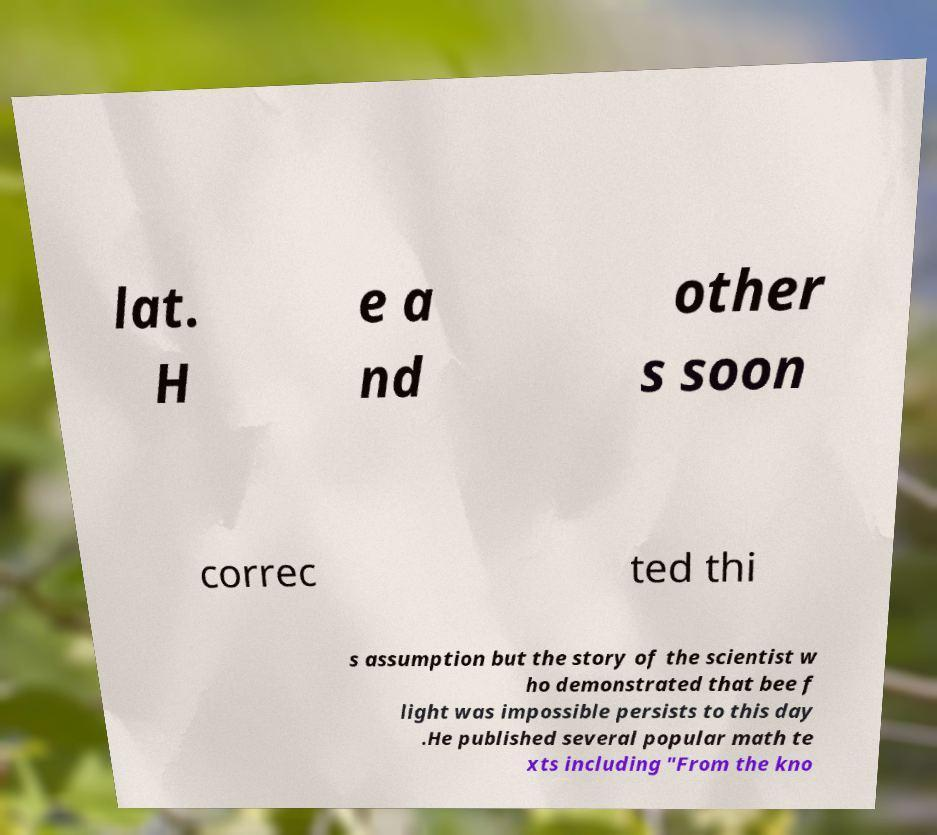What messages or text are displayed in this image? I need them in a readable, typed format. lat. H e a nd other s soon correc ted thi s assumption but the story of the scientist w ho demonstrated that bee f light was impossible persists to this day .He published several popular math te xts including "From the kno 